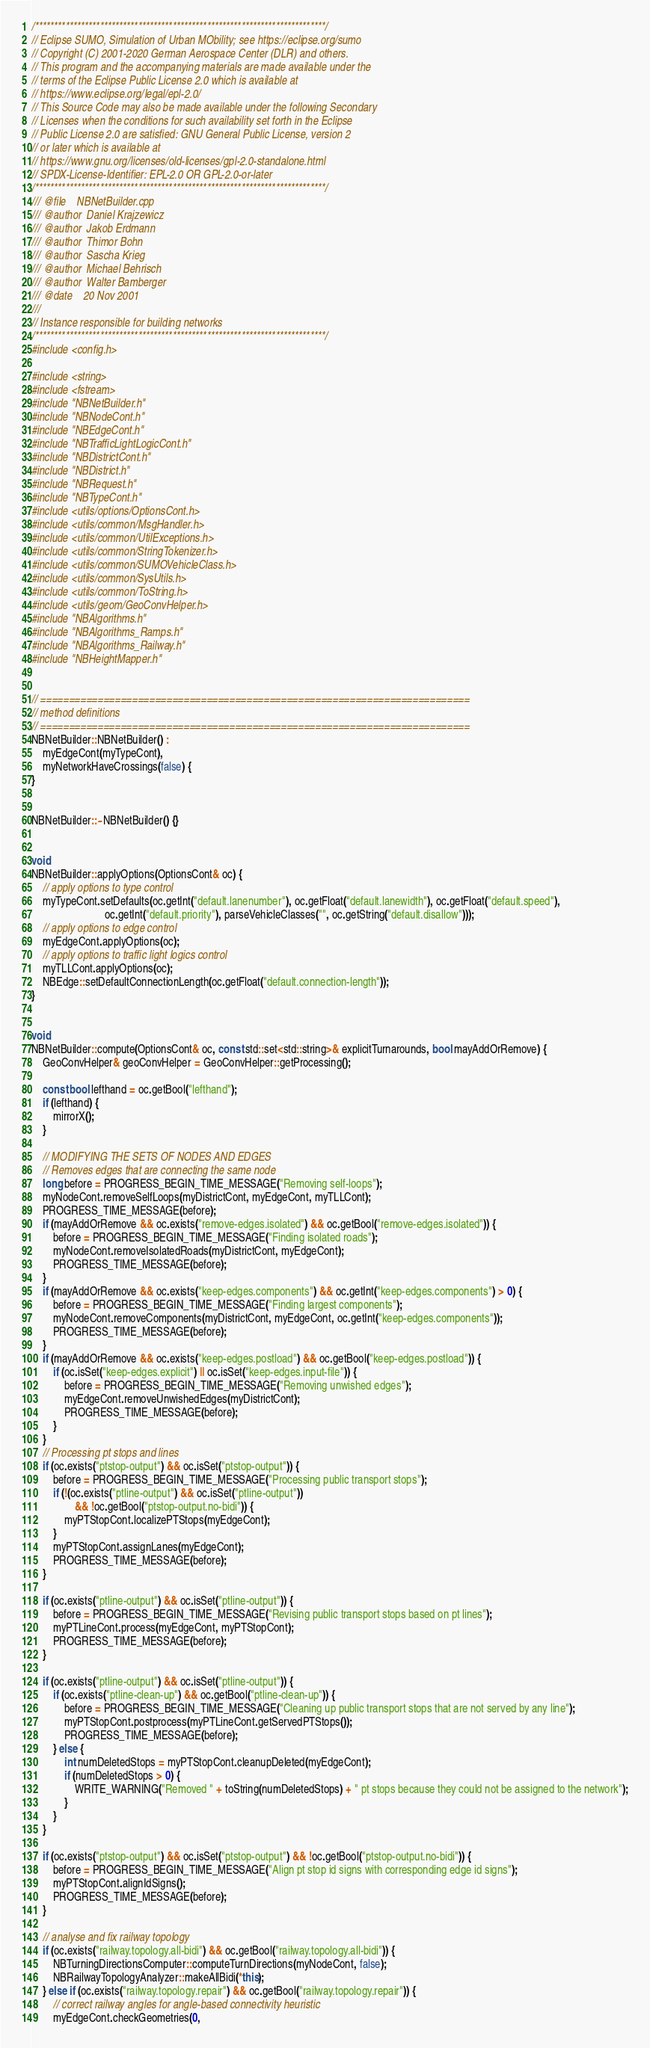Convert code to text. <code><loc_0><loc_0><loc_500><loc_500><_C++_>/****************************************************************************/
// Eclipse SUMO, Simulation of Urban MObility; see https://eclipse.org/sumo
// Copyright (C) 2001-2020 German Aerospace Center (DLR) and others.
// This program and the accompanying materials are made available under the
// terms of the Eclipse Public License 2.0 which is available at
// https://www.eclipse.org/legal/epl-2.0/
// This Source Code may also be made available under the following Secondary
// Licenses when the conditions for such availability set forth in the Eclipse
// Public License 2.0 are satisfied: GNU General Public License, version 2
// or later which is available at
// https://www.gnu.org/licenses/old-licenses/gpl-2.0-standalone.html
// SPDX-License-Identifier: EPL-2.0 OR GPL-2.0-or-later
/****************************************************************************/
/// @file    NBNetBuilder.cpp
/// @author  Daniel Krajzewicz
/// @author  Jakob Erdmann
/// @author  Thimor Bohn
/// @author  Sascha Krieg
/// @author  Michael Behrisch
/// @author  Walter Bamberger
/// @date    20 Nov 2001
///
// Instance responsible for building networks
/****************************************************************************/
#include <config.h>

#include <string>
#include <fstream>
#include "NBNetBuilder.h"
#include "NBNodeCont.h"
#include "NBEdgeCont.h"
#include "NBTrafficLightLogicCont.h"
#include "NBDistrictCont.h"
#include "NBDistrict.h"
#include "NBRequest.h"
#include "NBTypeCont.h"
#include <utils/options/OptionsCont.h>
#include <utils/common/MsgHandler.h>
#include <utils/common/UtilExceptions.h>
#include <utils/common/StringTokenizer.h>
#include <utils/common/SUMOVehicleClass.h>
#include <utils/common/SysUtils.h>
#include <utils/common/ToString.h>
#include <utils/geom/GeoConvHelper.h>
#include "NBAlgorithms.h"
#include "NBAlgorithms_Ramps.h"
#include "NBAlgorithms_Railway.h"
#include "NBHeightMapper.h"


// ===========================================================================
// method definitions
// ===========================================================================
NBNetBuilder::NBNetBuilder() :
    myEdgeCont(myTypeCont),
    myNetworkHaveCrossings(false) {
}


NBNetBuilder::~NBNetBuilder() {}


void
NBNetBuilder::applyOptions(OptionsCont& oc) {
    // apply options to type control
    myTypeCont.setDefaults(oc.getInt("default.lanenumber"), oc.getFloat("default.lanewidth"), oc.getFloat("default.speed"),
                           oc.getInt("default.priority"), parseVehicleClasses("", oc.getString("default.disallow")));
    // apply options to edge control
    myEdgeCont.applyOptions(oc);
    // apply options to traffic light logics control
    myTLLCont.applyOptions(oc);
    NBEdge::setDefaultConnectionLength(oc.getFloat("default.connection-length"));
}


void
NBNetBuilder::compute(OptionsCont& oc, const std::set<std::string>& explicitTurnarounds, bool mayAddOrRemove) {
    GeoConvHelper& geoConvHelper = GeoConvHelper::getProcessing();

    const bool lefthand = oc.getBool("lefthand");
    if (lefthand) {
        mirrorX();
    }

    // MODIFYING THE SETS OF NODES AND EDGES
    // Removes edges that are connecting the same node
    long before = PROGRESS_BEGIN_TIME_MESSAGE("Removing self-loops");
    myNodeCont.removeSelfLoops(myDistrictCont, myEdgeCont, myTLLCont);
    PROGRESS_TIME_MESSAGE(before);
    if (mayAddOrRemove && oc.exists("remove-edges.isolated") && oc.getBool("remove-edges.isolated")) {
        before = PROGRESS_BEGIN_TIME_MESSAGE("Finding isolated roads");
        myNodeCont.removeIsolatedRoads(myDistrictCont, myEdgeCont);
        PROGRESS_TIME_MESSAGE(before);
    }
    if (mayAddOrRemove && oc.exists("keep-edges.components") && oc.getInt("keep-edges.components") > 0) {
        before = PROGRESS_BEGIN_TIME_MESSAGE("Finding largest components");
        myNodeCont.removeComponents(myDistrictCont, myEdgeCont, oc.getInt("keep-edges.components"));
        PROGRESS_TIME_MESSAGE(before);
    }
    if (mayAddOrRemove && oc.exists("keep-edges.postload") && oc.getBool("keep-edges.postload")) {
        if (oc.isSet("keep-edges.explicit") || oc.isSet("keep-edges.input-file")) {
            before = PROGRESS_BEGIN_TIME_MESSAGE("Removing unwished edges");
            myEdgeCont.removeUnwishedEdges(myDistrictCont);
            PROGRESS_TIME_MESSAGE(before);
        }
    }
    // Processing pt stops and lines
    if (oc.exists("ptstop-output") && oc.isSet("ptstop-output")) {
        before = PROGRESS_BEGIN_TIME_MESSAGE("Processing public transport stops");
        if (!(oc.exists("ptline-output") && oc.isSet("ptline-output"))
                && !oc.getBool("ptstop-output.no-bidi")) {
            myPTStopCont.localizePTStops(myEdgeCont);
        }
        myPTStopCont.assignLanes(myEdgeCont);
        PROGRESS_TIME_MESSAGE(before);
    }

    if (oc.exists("ptline-output") && oc.isSet("ptline-output")) {
        before = PROGRESS_BEGIN_TIME_MESSAGE("Revising public transport stops based on pt lines");
        myPTLineCont.process(myEdgeCont, myPTStopCont);
        PROGRESS_TIME_MESSAGE(before);
    }

    if (oc.exists("ptline-output") && oc.isSet("ptline-output")) {
        if (oc.exists("ptline-clean-up") && oc.getBool("ptline-clean-up")) {
            before = PROGRESS_BEGIN_TIME_MESSAGE("Cleaning up public transport stops that are not served by any line");
            myPTStopCont.postprocess(myPTLineCont.getServedPTStops());
            PROGRESS_TIME_MESSAGE(before);
        } else {
            int numDeletedStops = myPTStopCont.cleanupDeleted(myEdgeCont);
            if (numDeletedStops > 0) {
                WRITE_WARNING("Removed " + toString(numDeletedStops) + " pt stops because they could not be assigned to the network");
            }
        }
    }

    if (oc.exists("ptstop-output") && oc.isSet("ptstop-output") && !oc.getBool("ptstop-output.no-bidi")) {
        before = PROGRESS_BEGIN_TIME_MESSAGE("Align pt stop id signs with corresponding edge id signs");
        myPTStopCont.alignIdSigns();
        PROGRESS_TIME_MESSAGE(before);
    }

    // analyse and fix railway topology
    if (oc.exists("railway.topology.all-bidi") && oc.getBool("railway.topology.all-bidi")) {
        NBTurningDirectionsComputer::computeTurnDirections(myNodeCont, false);
        NBRailwayTopologyAnalyzer::makeAllBidi(*this);
    } else if (oc.exists("railway.topology.repair") && oc.getBool("railway.topology.repair")) {
        // correct railway angles for angle-based connectivity heuristic
        myEdgeCont.checkGeometries(0,</code> 